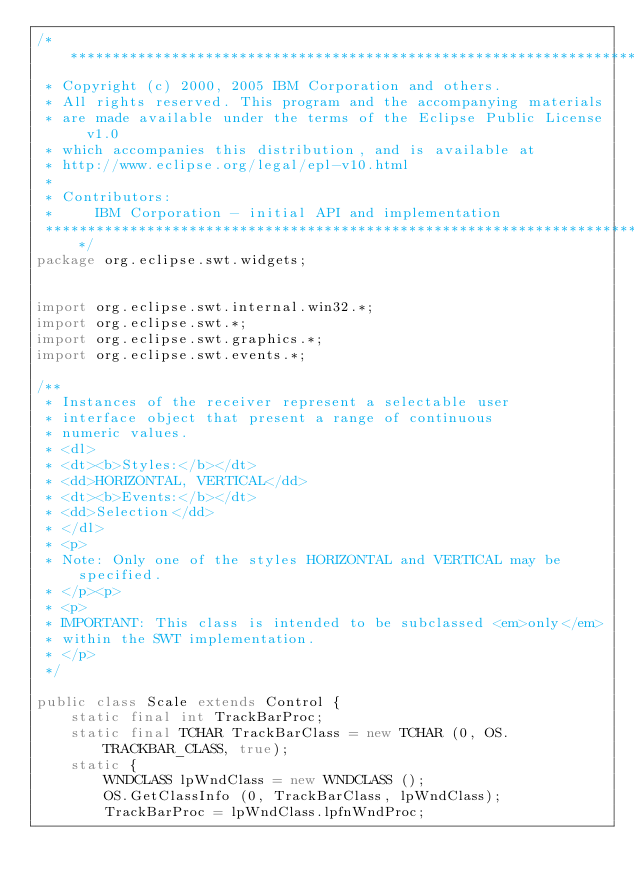<code> <loc_0><loc_0><loc_500><loc_500><_Java_>/*******************************************************************************
 * Copyright (c) 2000, 2005 IBM Corporation and others.
 * All rights reserved. This program and the accompanying materials
 * are made available under the terms of the Eclipse Public License v1.0
 * which accompanies this distribution, and is available at
 * http://www.eclipse.org/legal/epl-v10.html
 *
 * Contributors:
 *     IBM Corporation - initial API and implementation
 *******************************************************************************/
package org.eclipse.swt.widgets;

 
import org.eclipse.swt.internal.win32.*;
import org.eclipse.swt.*;
import org.eclipse.swt.graphics.*;
import org.eclipse.swt.events.*;

/**
 * Instances of the receiver represent a selectable user
 * interface object that present a range of continuous
 * numeric values.
 * <dl>
 * <dt><b>Styles:</b></dt>
 * <dd>HORIZONTAL, VERTICAL</dd>
 * <dt><b>Events:</b></dt>
 * <dd>Selection</dd>
 * </dl>
 * <p>
 * Note: Only one of the styles HORIZONTAL and VERTICAL may be specified.
 * </p><p>
 * <p>
 * IMPORTANT: This class is intended to be subclassed <em>only</em>
 * within the SWT implementation.
 * </p>
 */

public class Scale extends Control {
	static final int TrackBarProc;
	static final TCHAR TrackBarClass = new TCHAR (0, OS.TRACKBAR_CLASS, true);
	static {
		WNDCLASS lpWndClass = new WNDCLASS ();
		OS.GetClassInfo (0, TrackBarClass, lpWndClass);
		TrackBarProc = lpWndClass.lpfnWndProc;</code> 